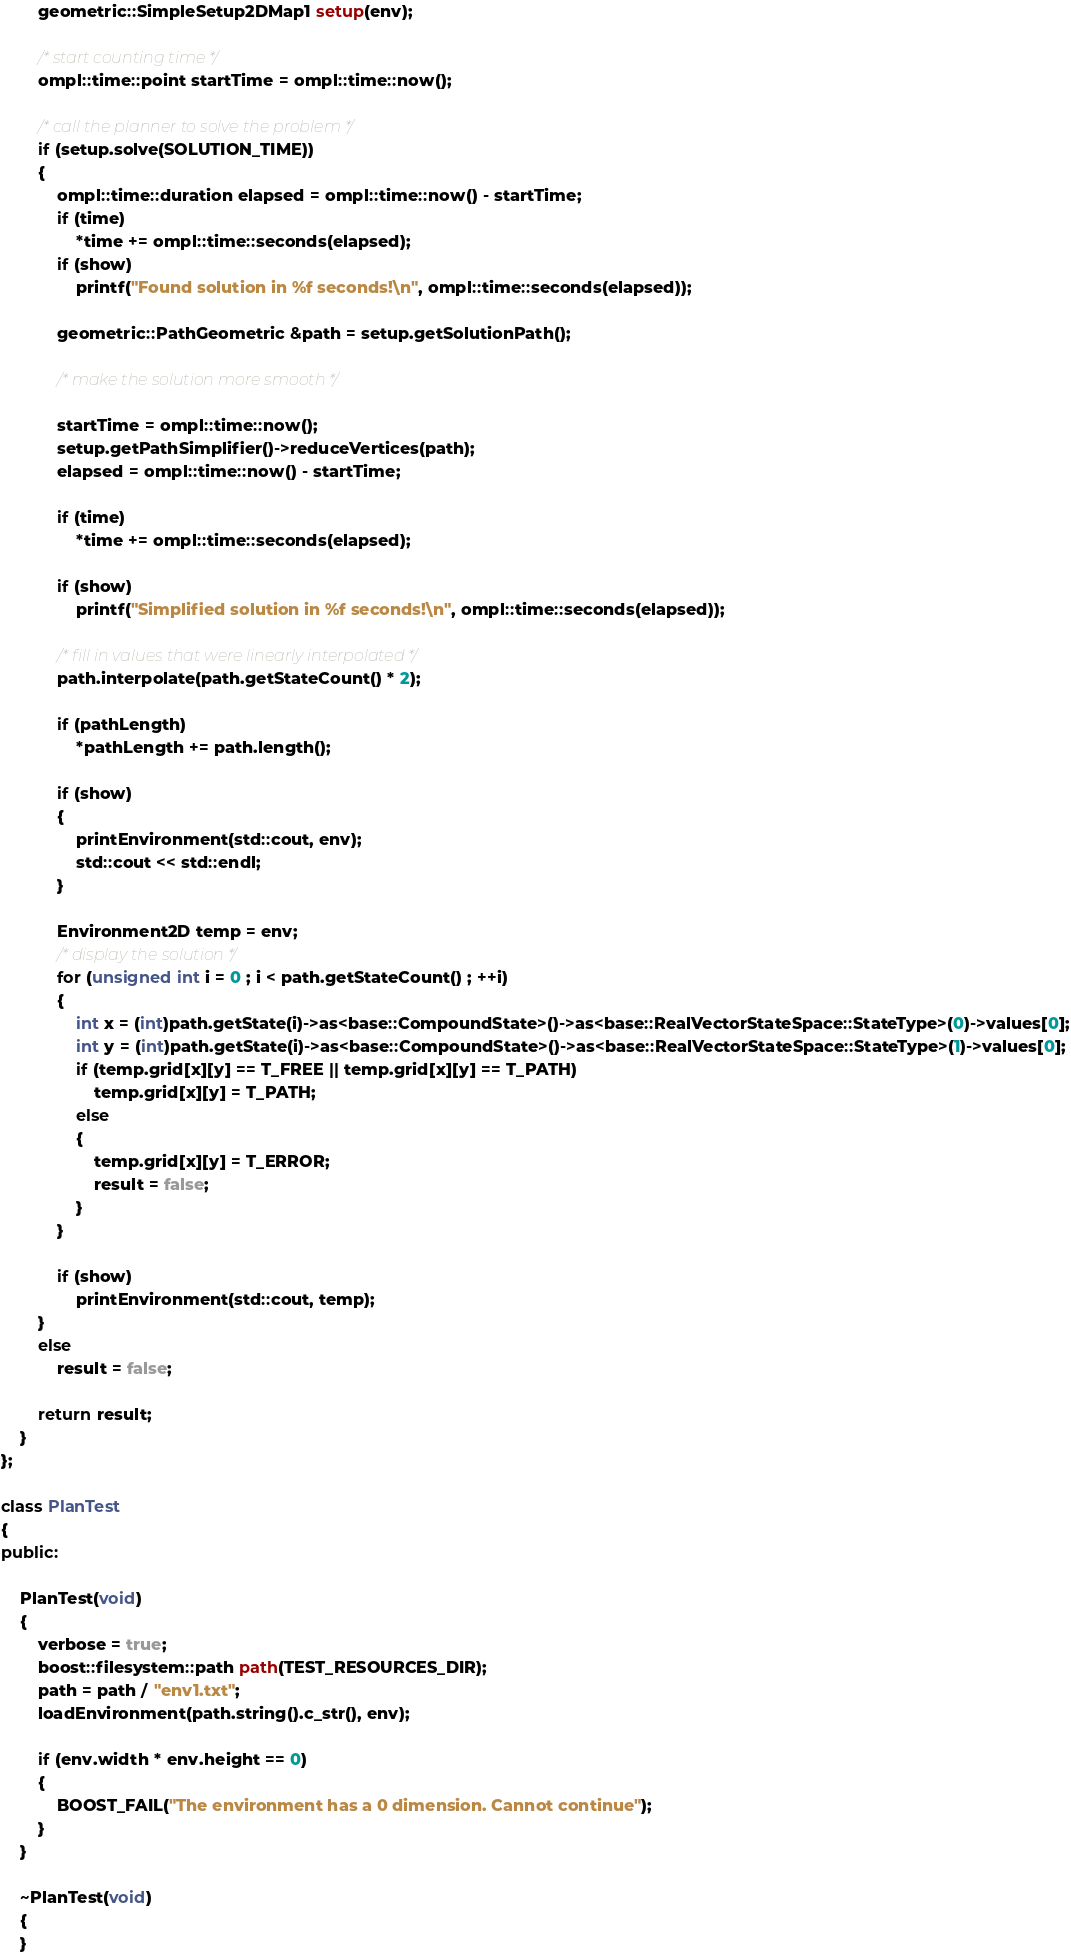Convert code to text. <code><loc_0><loc_0><loc_500><loc_500><_C++_>        geometric::SimpleSetup2DMap1 setup(env);

        /* start counting time */
        ompl::time::point startTime = ompl::time::now();

        /* call the planner to solve the problem */
        if (setup.solve(SOLUTION_TIME))
        {
            ompl::time::duration elapsed = ompl::time::now() - startTime;
            if (time)
                *time += ompl::time::seconds(elapsed);
            if (show)
                printf("Found solution in %f seconds!\n", ompl::time::seconds(elapsed));

            geometric::PathGeometric &path = setup.getSolutionPath();

            /* make the solution more smooth */

            startTime = ompl::time::now();
            setup.getPathSimplifier()->reduceVertices(path);
            elapsed = ompl::time::now() - startTime;

            if (time)
                *time += ompl::time::seconds(elapsed);

            if (show)
                printf("Simplified solution in %f seconds!\n", ompl::time::seconds(elapsed));

            /* fill in values that were linearly interpolated */
            path.interpolate(path.getStateCount() * 2);

            if (pathLength)
                *pathLength += path.length();

            if (show)
            {
                printEnvironment(std::cout, env);
                std::cout << std::endl;
            }

            Environment2D temp = env;
            /* display the solution */
            for (unsigned int i = 0 ; i < path.getStateCount() ; ++i)
            {
                int x = (int)path.getState(i)->as<base::CompoundState>()->as<base::RealVectorStateSpace::StateType>(0)->values[0];
                int y = (int)path.getState(i)->as<base::CompoundState>()->as<base::RealVectorStateSpace::StateType>(1)->values[0];
                if (temp.grid[x][y] == T_FREE || temp.grid[x][y] == T_PATH)
                    temp.grid[x][y] = T_PATH;
                else
                {
                    temp.grid[x][y] = T_ERROR;
                    result = false;
                }
            }

            if (show)
                printEnvironment(std::cout, temp);
        }
        else
            result = false;

        return result;
    }
};

class PlanTest
{
public:

    PlanTest(void)
    {
        verbose = true;
        boost::filesystem::path path(TEST_RESOURCES_DIR);
        path = path / "env1.txt";
        loadEnvironment(path.string().c_str(), env);

        if (env.width * env.height == 0)
        {
            BOOST_FAIL("The environment has a 0 dimension. Cannot continue");
        }
    }

    ~PlanTest(void)
    {
    }
</code> 